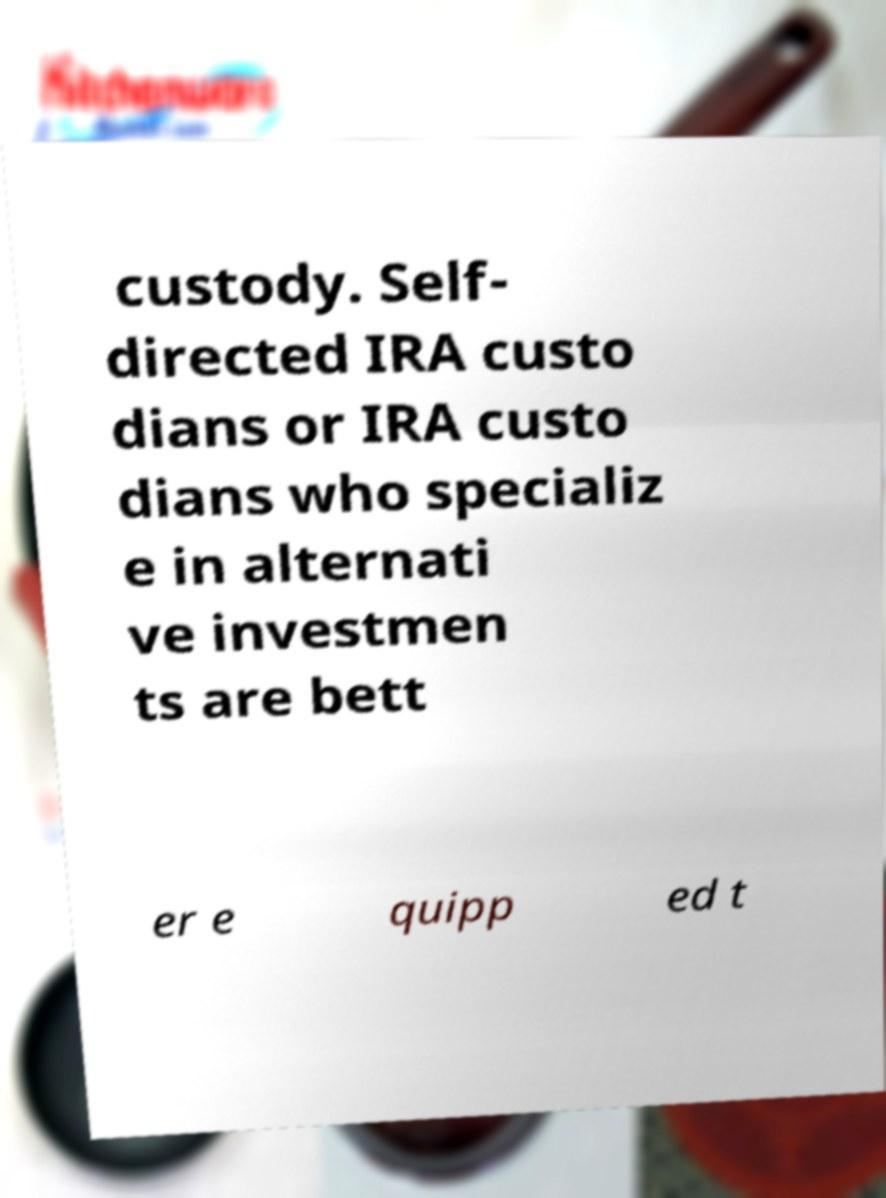I need the written content from this picture converted into text. Can you do that? custody. Self- directed IRA custo dians or IRA custo dians who specializ e in alternati ve investmen ts are bett er e quipp ed t 